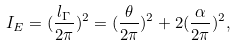<formula> <loc_0><loc_0><loc_500><loc_500>I _ { E } = ( \frac { l _ { \Gamma } } { 2 \pi } ) ^ { 2 } = ( \frac { \theta } { 2 \pi } ) ^ { 2 } + 2 ( \frac { \alpha } { 2 \pi } ) ^ { 2 } ,</formula> 